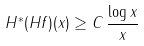Convert formula to latex. <formula><loc_0><loc_0><loc_500><loc_500>H ^ { * } ( H f ) ( x ) \geq C \, \frac { \log x } { x }</formula> 